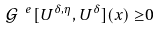<formula> <loc_0><loc_0><loc_500><loc_500>\mathcal { G } ^ { \ e } [ U ^ { \delta , \eta } , U ^ { \delta } ] ( x ) \geq & 0</formula> 